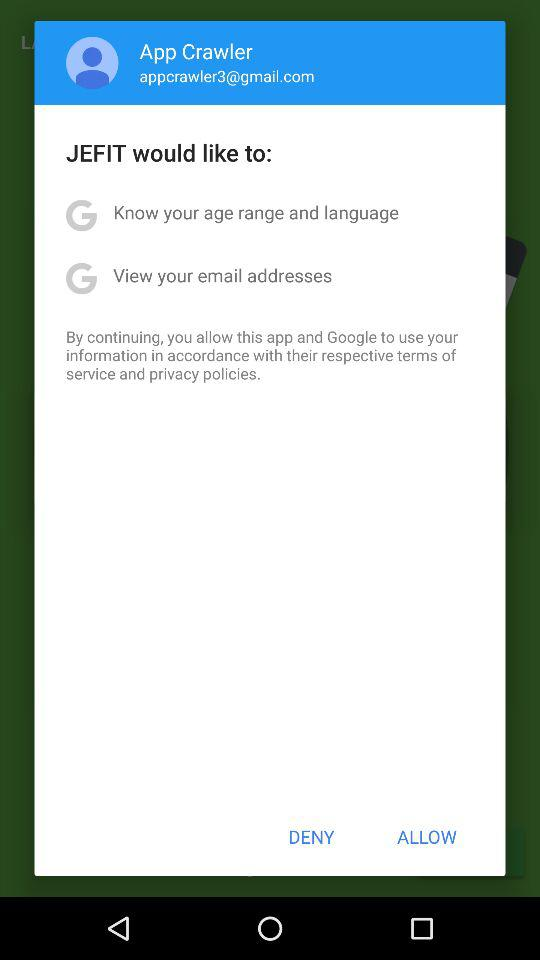What is the user name? The user name is App Crawler. 